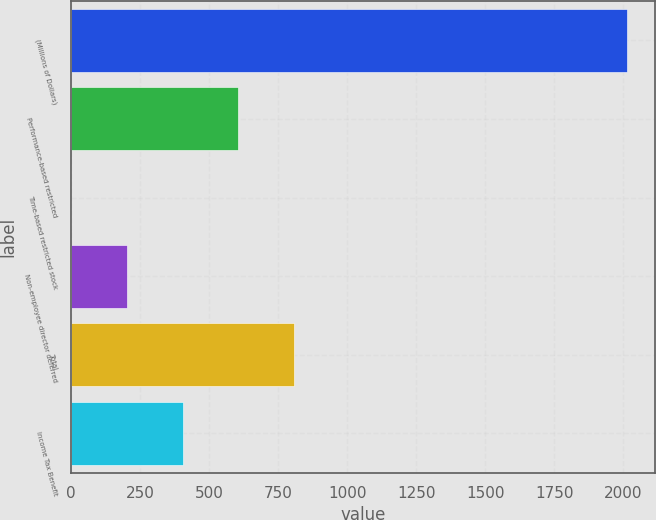<chart> <loc_0><loc_0><loc_500><loc_500><bar_chart><fcel>(Millions of Dollars)<fcel>Performance-based restricted<fcel>Time-based restricted stock<fcel>Non-employee director deferred<fcel>Total<fcel>Income Tax Benefit<nl><fcel>2013<fcel>605.3<fcel>2<fcel>203.1<fcel>806.4<fcel>404.2<nl></chart> 